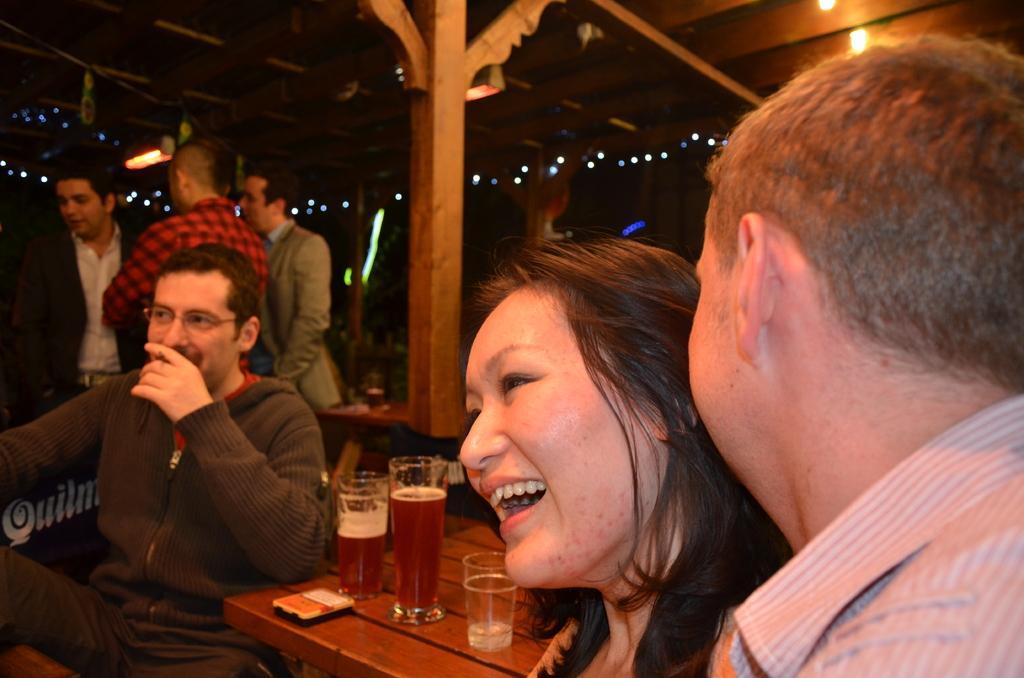Could you give a brief overview of what you see in this image? This picture shows some people were sitting in the chairs in front of a table on which some glasses were present. In the background there are some people standing and we can observe a pillar here. 